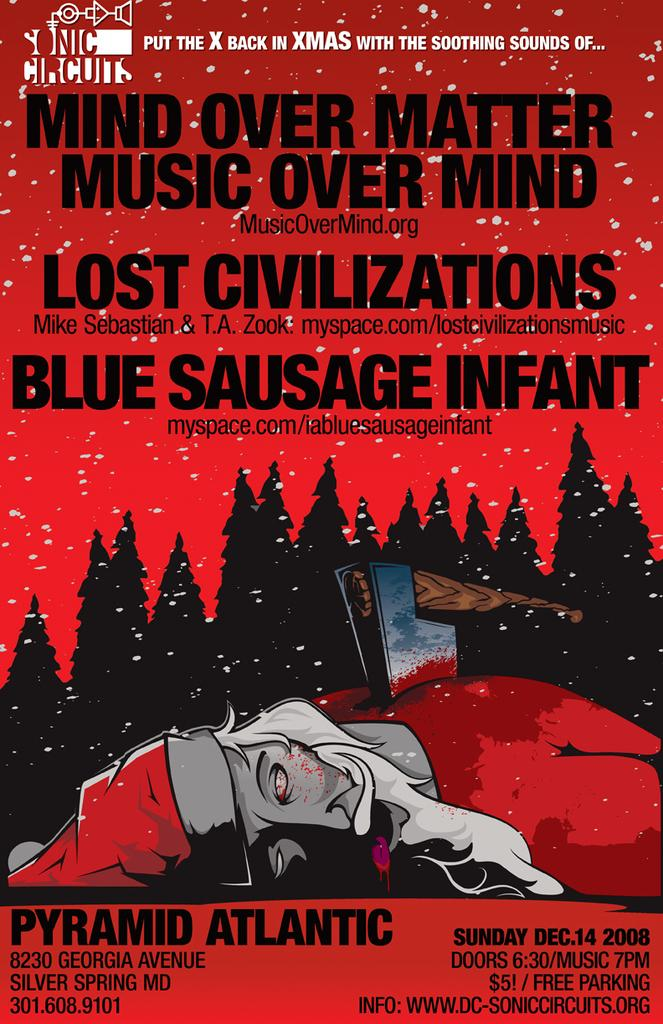What is present in the picture? There is a poster in the picture. What can be found on the poster? The poster contains images and text. What is the color of the poster? The poster is red in color. What type of toy can be seen on the poster? There is no toy present on the poster; it contains images and text related to other subjects. 